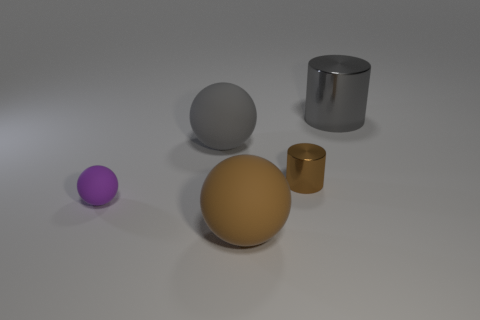Subtract all brown spheres. How many spheres are left? 2 Add 3 big blue rubber cylinders. How many objects exist? 8 Subtract all brown balls. How many balls are left? 2 Subtract 1 cylinders. How many cylinders are left? 1 Subtract 1 brown balls. How many objects are left? 4 Subtract all balls. How many objects are left? 2 Subtract all purple cylinders. Subtract all gray blocks. How many cylinders are left? 2 Subtract all red cylinders. How many purple spheres are left? 1 Subtract all brown cylinders. Subtract all small purple things. How many objects are left? 3 Add 1 large balls. How many large balls are left? 3 